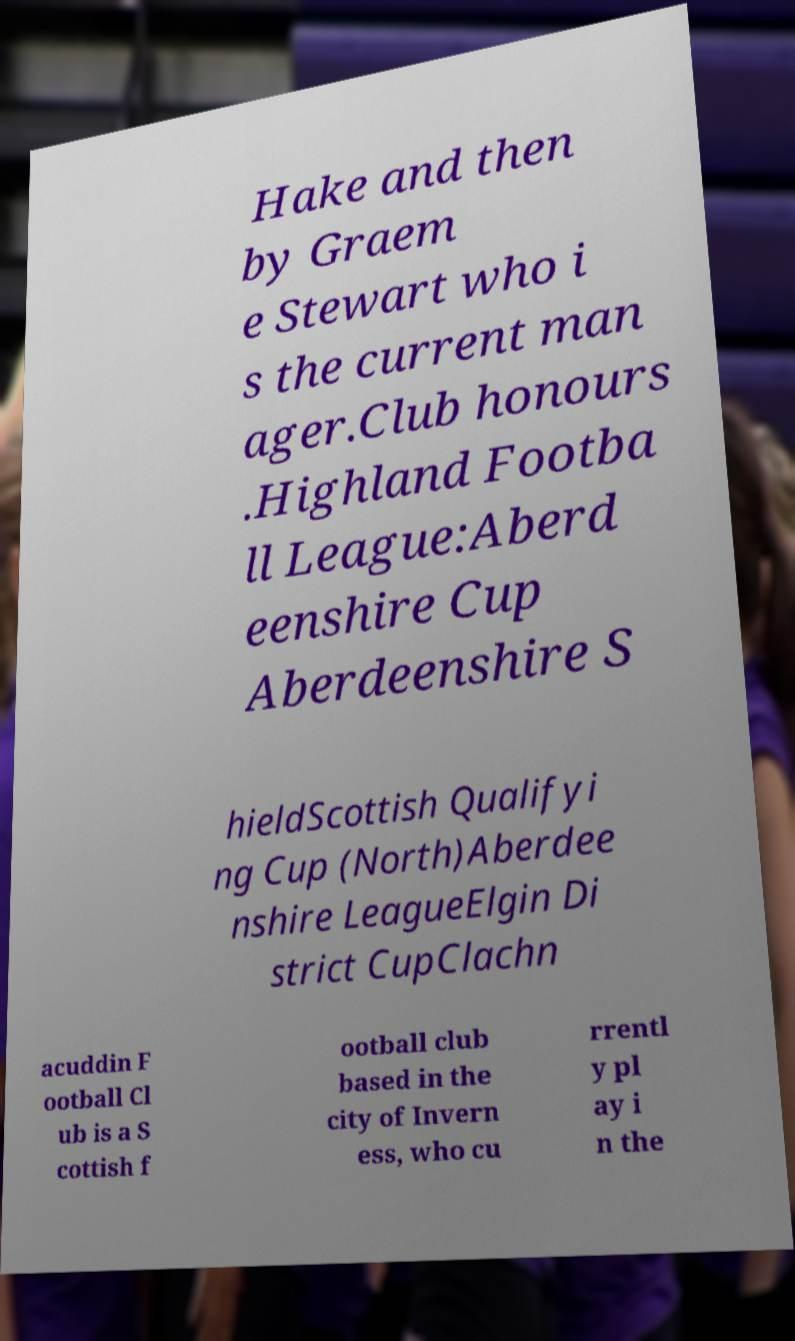What messages or text are displayed in this image? I need them in a readable, typed format. Hake and then by Graem e Stewart who i s the current man ager.Club honours .Highland Footba ll League:Aberd eenshire Cup Aberdeenshire S hieldScottish Qualifyi ng Cup (North)Aberdee nshire LeagueElgin Di strict CupClachn acuddin F ootball Cl ub is a S cottish f ootball club based in the city of Invern ess, who cu rrentl y pl ay i n the 